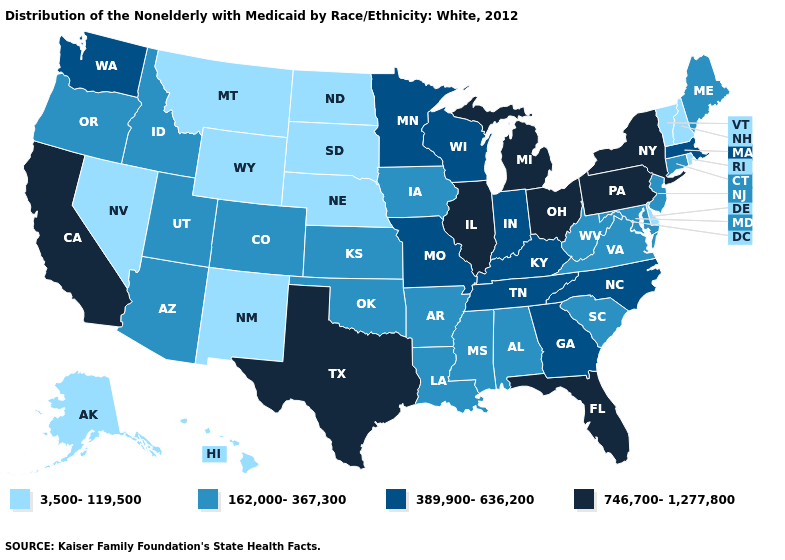Name the states that have a value in the range 746,700-1,277,800?
Short answer required. California, Florida, Illinois, Michigan, New York, Ohio, Pennsylvania, Texas. Name the states that have a value in the range 746,700-1,277,800?
Be succinct. California, Florida, Illinois, Michigan, New York, Ohio, Pennsylvania, Texas. What is the lowest value in the USA?
Short answer required. 3,500-119,500. Which states have the lowest value in the Northeast?
Write a very short answer. New Hampshire, Rhode Island, Vermont. Name the states that have a value in the range 3,500-119,500?
Keep it brief. Alaska, Delaware, Hawaii, Montana, Nebraska, Nevada, New Hampshire, New Mexico, North Dakota, Rhode Island, South Dakota, Vermont, Wyoming. Name the states that have a value in the range 162,000-367,300?
Concise answer only. Alabama, Arizona, Arkansas, Colorado, Connecticut, Idaho, Iowa, Kansas, Louisiana, Maine, Maryland, Mississippi, New Jersey, Oklahoma, Oregon, South Carolina, Utah, Virginia, West Virginia. What is the value of Louisiana?
Concise answer only. 162,000-367,300. What is the value of Tennessee?
Keep it brief. 389,900-636,200. Which states have the lowest value in the South?
Short answer required. Delaware. What is the value of New Jersey?
Concise answer only. 162,000-367,300. Which states have the lowest value in the South?
Concise answer only. Delaware. Name the states that have a value in the range 3,500-119,500?
Be succinct. Alaska, Delaware, Hawaii, Montana, Nebraska, Nevada, New Hampshire, New Mexico, North Dakota, Rhode Island, South Dakota, Vermont, Wyoming. What is the highest value in the USA?
Short answer required. 746,700-1,277,800. What is the value of Pennsylvania?
Keep it brief. 746,700-1,277,800. 